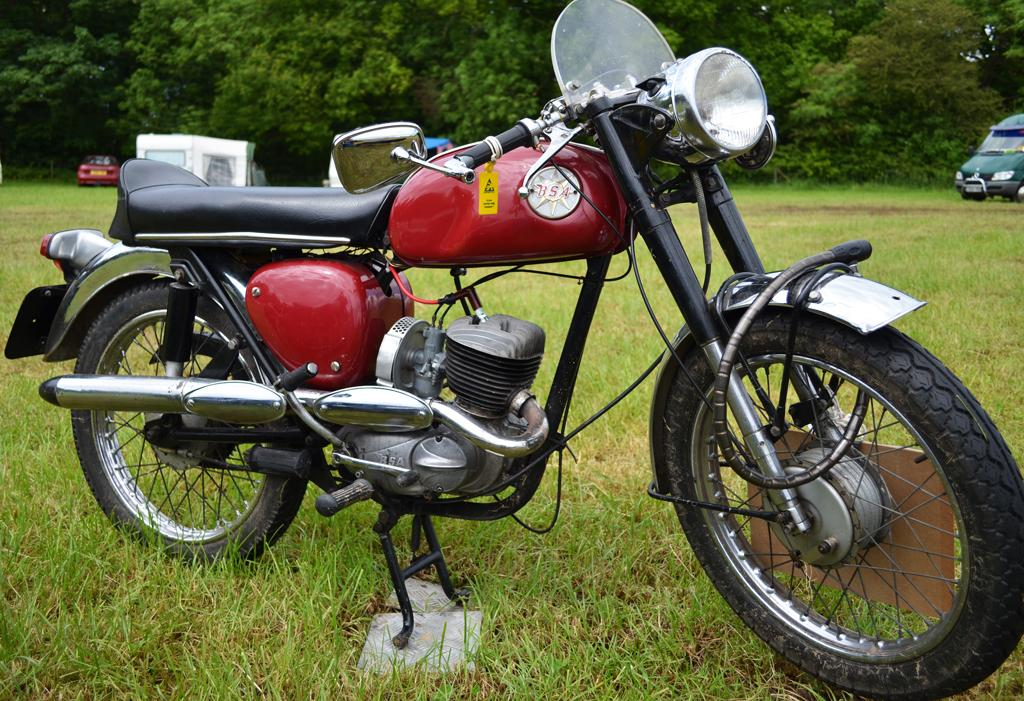What types of vehicles are in the image? The image contains vehicles, but the specific types cannot be determined from the provided facts. What type of natural environment is visible in the image? The image contains grass and trees. Can you describe a specific feature of one of the vehicles? The headlight of a vehicle is visible in the image. What type of vessel is visible in the image? There is no vessel present in the image. Can you tell me how many times the toothbrush is used in the image? There is no toothbrush present in the image. 